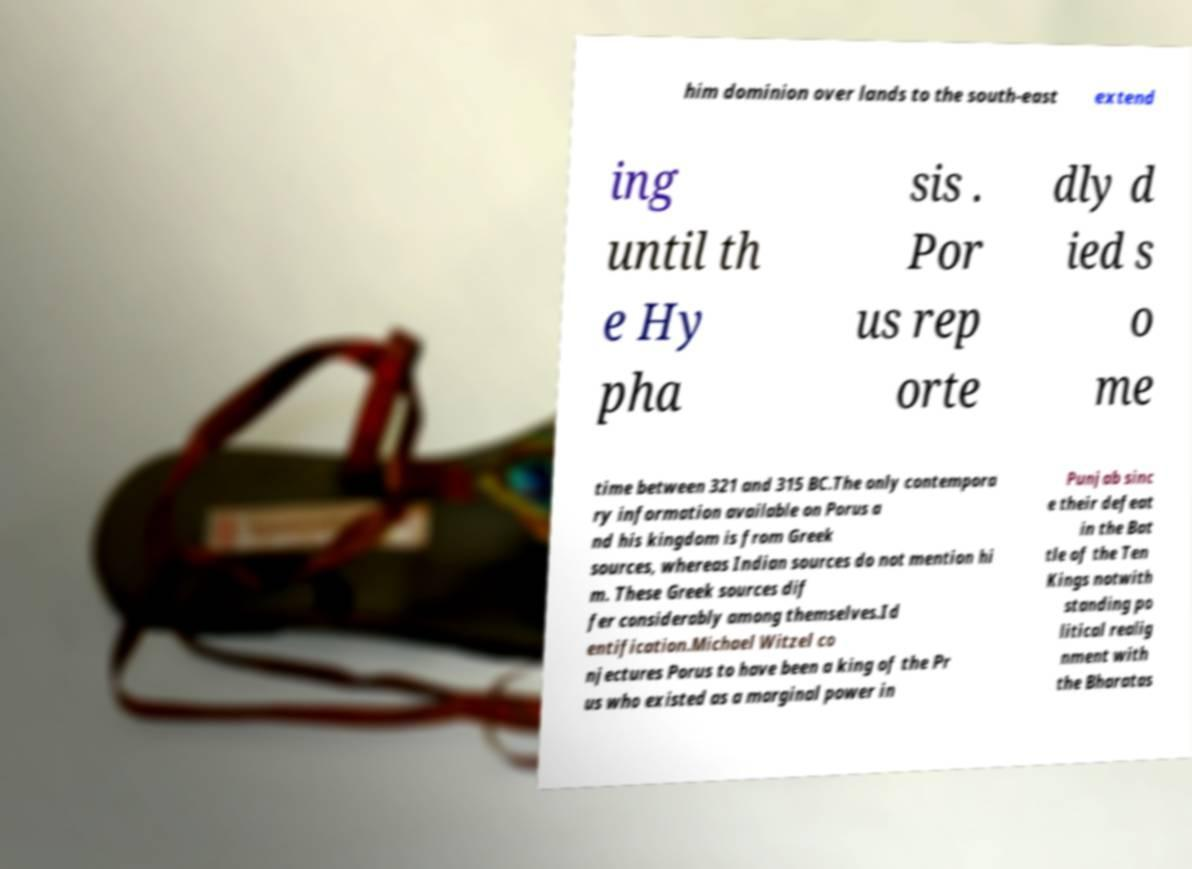I need the written content from this picture converted into text. Can you do that? him dominion over lands to the south-east extend ing until th e Hy pha sis . Por us rep orte dly d ied s o me time between 321 and 315 BC.The only contempora ry information available on Porus a nd his kingdom is from Greek sources, whereas Indian sources do not mention hi m. These Greek sources dif fer considerably among themselves.Id entification.Michael Witzel co njectures Porus to have been a king of the Pr us who existed as a marginal power in Punjab sinc e their defeat in the Bat tle of the Ten Kings notwith standing po litical realig nment with the Bharatas 